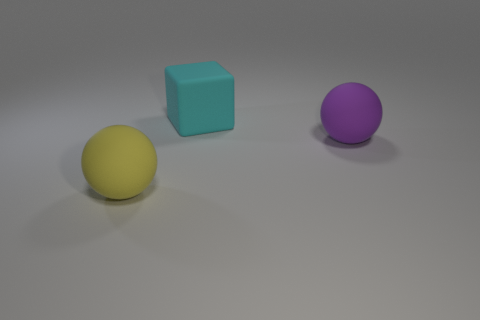What is the shape of the large purple object that is made of the same material as the cyan thing?
Keep it short and to the point. Sphere. Are there fewer yellow matte objects on the right side of the block than gray matte balls?
Offer a very short reply. No. There is a ball that is on the left side of the purple sphere; what is its material?
Keep it short and to the point. Rubber. What number of other things are there of the same size as the yellow object?
Provide a succinct answer. 2. There is a yellow ball; is it the same size as the matte thing to the right of the large rubber cube?
Keep it short and to the point. Yes. There is a large purple rubber object behind the large matte object that is in front of the large ball that is right of the large yellow matte thing; what shape is it?
Your response must be concise. Sphere. Are there fewer yellow spheres than rubber things?
Provide a short and direct response. Yes. There is a yellow matte ball; are there any big purple matte spheres to the right of it?
Keep it short and to the point. Yes. What is the shape of the object that is both on the right side of the big yellow rubber thing and left of the big purple matte ball?
Your answer should be very brief. Cube. Are there any other large matte things of the same shape as the large yellow rubber thing?
Your response must be concise. Yes. 